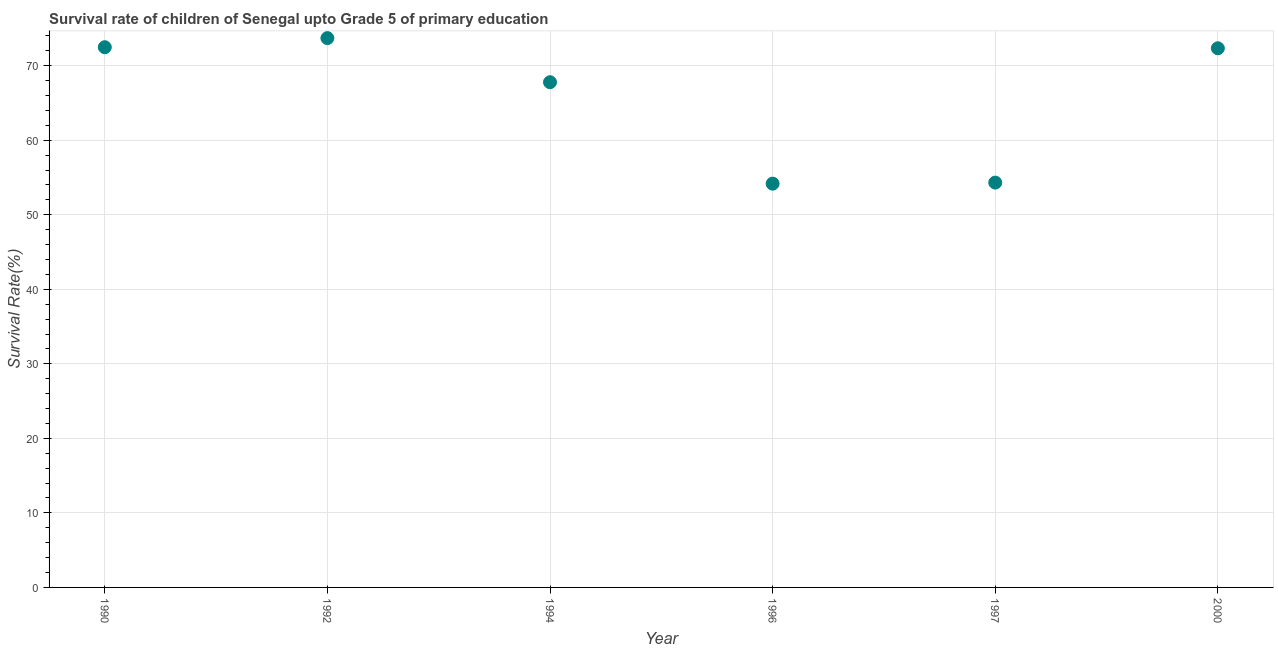What is the survival rate in 1996?
Make the answer very short. 54.18. Across all years, what is the maximum survival rate?
Ensure brevity in your answer.  73.7. Across all years, what is the minimum survival rate?
Your answer should be very brief. 54.18. What is the sum of the survival rate?
Your response must be concise. 394.8. What is the difference between the survival rate in 1992 and 1994?
Ensure brevity in your answer.  5.92. What is the average survival rate per year?
Your answer should be compact. 65.8. What is the median survival rate?
Your response must be concise. 70.06. What is the ratio of the survival rate in 1990 to that in 1992?
Give a very brief answer. 0.98. What is the difference between the highest and the second highest survival rate?
Ensure brevity in your answer.  1.22. Is the sum of the survival rate in 1997 and 2000 greater than the maximum survival rate across all years?
Offer a terse response. Yes. What is the difference between the highest and the lowest survival rate?
Ensure brevity in your answer.  19.53. In how many years, is the survival rate greater than the average survival rate taken over all years?
Your answer should be very brief. 4. Does the survival rate monotonically increase over the years?
Keep it short and to the point. No. How many dotlines are there?
Provide a succinct answer. 1. What is the difference between two consecutive major ticks on the Y-axis?
Keep it short and to the point. 10. Are the values on the major ticks of Y-axis written in scientific E-notation?
Give a very brief answer. No. What is the title of the graph?
Ensure brevity in your answer.  Survival rate of children of Senegal upto Grade 5 of primary education. What is the label or title of the X-axis?
Your response must be concise. Year. What is the label or title of the Y-axis?
Keep it short and to the point. Survival Rate(%). What is the Survival Rate(%) in 1990?
Ensure brevity in your answer.  72.48. What is the Survival Rate(%) in 1992?
Your answer should be compact. 73.7. What is the Survival Rate(%) in 1994?
Keep it short and to the point. 67.79. What is the Survival Rate(%) in 1996?
Provide a succinct answer. 54.18. What is the Survival Rate(%) in 1997?
Keep it short and to the point. 54.32. What is the Survival Rate(%) in 2000?
Your answer should be very brief. 72.34. What is the difference between the Survival Rate(%) in 1990 and 1992?
Give a very brief answer. -1.22. What is the difference between the Survival Rate(%) in 1990 and 1994?
Your answer should be very brief. 4.7. What is the difference between the Survival Rate(%) in 1990 and 1996?
Your answer should be very brief. 18.31. What is the difference between the Survival Rate(%) in 1990 and 1997?
Offer a very short reply. 18.17. What is the difference between the Survival Rate(%) in 1990 and 2000?
Provide a succinct answer. 0.14. What is the difference between the Survival Rate(%) in 1992 and 1994?
Your answer should be compact. 5.92. What is the difference between the Survival Rate(%) in 1992 and 1996?
Provide a short and direct response. 19.53. What is the difference between the Survival Rate(%) in 1992 and 1997?
Give a very brief answer. 19.39. What is the difference between the Survival Rate(%) in 1992 and 2000?
Offer a terse response. 1.36. What is the difference between the Survival Rate(%) in 1994 and 1996?
Your answer should be compact. 13.61. What is the difference between the Survival Rate(%) in 1994 and 1997?
Your response must be concise. 13.47. What is the difference between the Survival Rate(%) in 1994 and 2000?
Provide a short and direct response. -4.55. What is the difference between the Survival Rate(%) in 1996 and 1997?
Provide a succinct answer. -0.14. What is the difference between the Survival Rate(%) in 1996 and 2000?
Your answer should be compact. -18.16. What is the difference between the Survival Rate(%) in 1997 and 2000?
Provide a succinct answer. -18.02. What is the ratio of the Survival Rate(%) in 1990 to that in 1994?
Offer a very short reply. 1.07. What is the ratio of the Survival Rate(%) in 1990 to that in 1996?
Offer a very short reply. 1.34. What is the ratio of the Survival Rate(%) in 1990 to that in 1997?
Make the answer very short. 1.33. What is the ratio of the Survival Rate(%) in 1990 to that in 2000?
Ensure brevity in your answer.  1. What is the ratio of the Survival Rate(%) in 1992 to that in 1994?
Provide a succinct answer. 1.09. What is the ratio of the Survival Rate(%) in 1992 to that in 1996?
Offer a terse response. 1.36. What is the ratio of the Survival Rate(%) in 1992 to that in 1997?
Give a very brief answer. 1.36. What is the ratio of the Survival Rate(%) in 1992 to that in 2000?
Your answer should be very brief. 1.02. What is the ratio of the Survival Rate(%) in 1994 to that in 1996?
Your answer should be compact. 1.25. What is the ratio of the Survival Rate(%) in 1994 to that in 1997?
Give a very brief answer. 1.25. What is the ratio of the Survival Rate(%) in 1994 to that in 2000?
Give a very brief answer. 0.94. What is the ratio of the Survival Rate(%) in 1996 to that in 2000?
Give a very brief answer. 0.75. What is the ratio of the Survival Rate(%) in 1997 to that in 2000?
Your response must be concise. 0.75. 